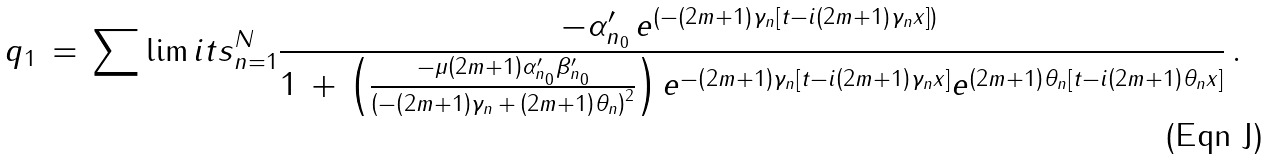<formula> <loc_0><loc_0><loc_500><loc_500>q _ { 1 } \, = \, \sum \lim i t s _ { n = 1 } ^ { N } \frac { - \alpha _ { n _ { 0 } } ^ { \prime } \, e ^ { \left ( - \left ( 2 m + 1 \right ) \gamma _ { n } \left [ t - i \left ( 2 m + 1 \right ) \gamma _ { n } x \right ] \right ) } \, } { 1 \, + \, \left ( \frac { - \mu \left ( 2 m + 1 \right ) \alpha _ { n _ { 0 } } ^ { \prime } \beta _ { n _ { 0 } } ^ { \prime } } { \left ( - \left ( 2 m + 1 \right ) \gamma _ { n } \, + \, \left ( 2 m + 1 \right ) \theta _ { n } \right ) ^ { 2 } } \right ) e ^ { - \left ( 2 m + 1 \right ) \gamma _ { n } \left [ t - i \left ( 2 m + 1 \right ) \gamma _ { n } x \right ] } e ^ { \left ( 2 m + 1 \right ) \theta _ { n } \left [ t - i \left ( 2 m + 1 \right ) \theta _ { n } x \right ] } } \, .</formula> 